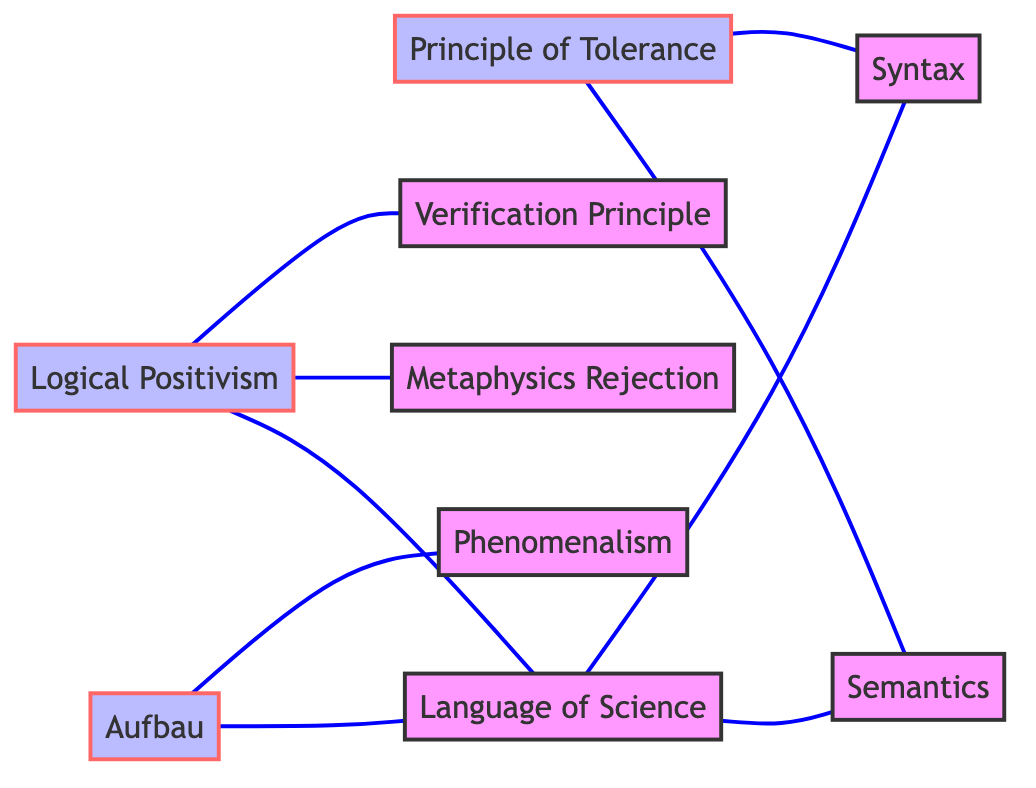What is the total number of nodes in the diagram? The diagram includes the following nodes: Logical Positivism, Aufbau, Principle of Tolerance, Verification Principle, Phenomenalism, Language of Science, Metaphysics Rejection, Syntax, and Semantics. Counting these gives a total of 9 nodes.
Answer: 9 Which concept is directly connected to both Logical Positivism and Syntax? To find the answer, we look at the edges that connect nodes. Syntax has edges connecting to Principle of Tolerance and Language of Science, but neither connects directly to Logical Positivism. However, Language of Science is connected to Logical Positivism and Syntax, making Language of Science the intermediate that connects them.
Answer: Language of Science How many edges are there in total? The edges in the diagram are: Logical Positivism to Verification Principle, Logical Positivism to Metaphysics Rejection, Logical Positivism to Language of Science, Aufbau to Phenomenalism, Aufbau to Language of Science, Principle of Tolerance to Syntax, Principle of Tolerance to Semantics, Language of Science to Syntax, and Language of Science to Semantics. Counting these gives a total of 9 edges.
Answer: 9 What is the relationship between the Aufbau and Phenomenalism? The direct connection between these two nodes forms an edge, meaning they are related. Specifically, Aufbau is linked to Phenomenalism, indicating that Phenomenalism is an aspect or consequence of the Aufbau project.
Answer: Directly connected Which concept does the Principle of Tolerance NOT connect to in the diagram? To answer this, we examine the connections of the Principle of Tolerance. It connects to Syntax and Semantics but does not have a direct connection to Logical Positivism, Verification Principle, Metaphysics Rejection, or Phenomenalism. Thus, the answer is one of those concepts.
Answer: Logical Positivism Which concepts are connected to Language of Science? We check the connections: Language of Science has edges to Logical Positivism, Syntax, and Semantics. Thus, its connected concepts are Logical Positivism, Syntax, and Semantics.
Answer: Logical Positivism, Syntax, Semantics What principle is part of the Logical Positivism movement that rejects metaphysics? The description for Metaphysics Rejection under Logical Positivism clearly states that it comprises the dismissal of metaphysical statements as meaningless. This shows that Metaphysics Rejection is a specific principle of Logical Positivism.
Answer: Metaphysics Rejection How do Syntax and Semantics relate according to the Principle of Tolerance? Both Syntax and Semantics are connected to the Principle of Tolerance, indicating that within this framework, the organization of symbols (Syntax) and their meanings (Semantics) are both recognized as valid and important aspects.
Answer: Both are connected 